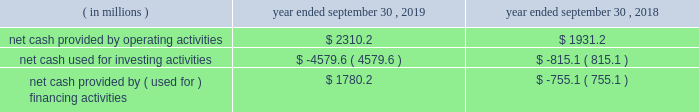Credit facilities .
As such , our foreign cash and cash equivalents are not expected to be a key source of liquidity to our domestic operations .
At september 30 , 2019 , we had approximately $ 2.9 billion of availability under our committed credit facilities , primarily under our revolving credit facility , the majority of which matures on july 1 , 2022 .
This liquidity may be used to provide for ongoing working capital needs and for other general corporate purposes , including acquisitions , dividends and stock repurchases .
Certain restrictive covenants govern our maximum availability under the credit facilities .
We test and report our compliance with these covenants as required and we were in compliance with all of these covenants at september 30 , 2019 .
At september 30 , 2019 , we had $ 129.8 million of outstanding letters of credit not drawn cash and cash equivalents were $ 151.6 million at september 30 , 2019 and $ 636.8 million at september 30 , 2018 .
We used a significant portion of the cash and cash equivalents on hand at september 30 , 2018 in connection with the closing of the kapstone acquisition .
Primarily all of the cash and cash equivalents at september 30 , 2019 were held outside of the u.s .
At september 30 , 2019 , total debt was $ 10063.4 million , $ 561.1 million of which was current .
At september 30 , 2018 , total debt was $ 6415.2 million , $ 740.7 million of which was current .
The increase in debt was primarily related to the kapstone acquisition .
Cash flow activity .
Net cash provided by operating activities during fiscal 2019 increased $ 379.0 million from fiscal 2018 primarily due to higher cash earnings and a $ 340.3 million net decrease in the use of working capital compared to the prior year .
As a result of the retrospective adoption of asu 2016-15 and asu 2016-18 ( each as hereinafter defined ) as discussed in 201cnote 1 .
Description of business and summary of significant accounting policies 201d of the notes to consolidated financial statements , net cash provided by operating activities for fiscal 2018 was reduced by $ 489.7 million and cash provided by investing activities increased $ 483.8 million , primarily for the change in classification of proceeds received for beneficial interests obtained for transferring trade receivables in securitization transactions .
Net cash used for investing activities of $ 4579.6 million in fiscal 2019 consisted primarily of $ 3374.2 million for cash paid for the purchase of businesses , net of cash acquired ( excluding the assumption of debt ) , primarily related to the kapstone acquisition , and $ 1369.1 million for capital expenditures that were partially offset by $ 119.1 million of proceeds from the sale of property , plant and equipment primarily related to the sale of our atlanta beverage facility , $ 33.2 million of proceeds from corporate owned life insurance benefits and $ 25.5 million of proceeds from property , plant and equipment insurance proceeds related to the panama city , fl mill .
Net cash used for investing activities of $ 815.1 million in fiscal 2018 consisted primarily of $ 999.9 million for capital expenditures , $ 239.9 million for cash paid for the purchase of businesses , net of cash acquired primarily related to the plymouth acquisition and the schl fcter acquisition , and $ 108.0 million for an investment in grupo gondi .
These investments were partially offset by $ 461.6 million of cash receipts on sold trade receivables as a result of the adoption of asu 2016-15 , $ 24.0 million of proceeds from the sale of certain affiliates as well as our solid waste management brokerage services business and $ 23.3 million of proceeds from the sale of property , plant and equipment .
In fiscal 2019 , net cash provided by financing activities of $ 1780.2 million consisted primarily of a net increase in debt of $ 2314.6 million , primarily related to the kapstone acquisition and partially offset by cash dividends paid to stockholders of $ 467.9 million and purchases of common stock of $ 88.6 million .
In fiscal 2018 , net cash used for financing activities of $ 755.1 million consisted primarily of cash dividends paid to stockholders of $ 440.9 million and purchases of common stock of $ 195.1 million and net repayments of debt of $ 120.1 million. .
In 2018 what was the percent of the net cash used for financing activities used for the purchase of purchases of common stock? 
Computations: (195.1 / 755.1)
Answer: 0.25838. 